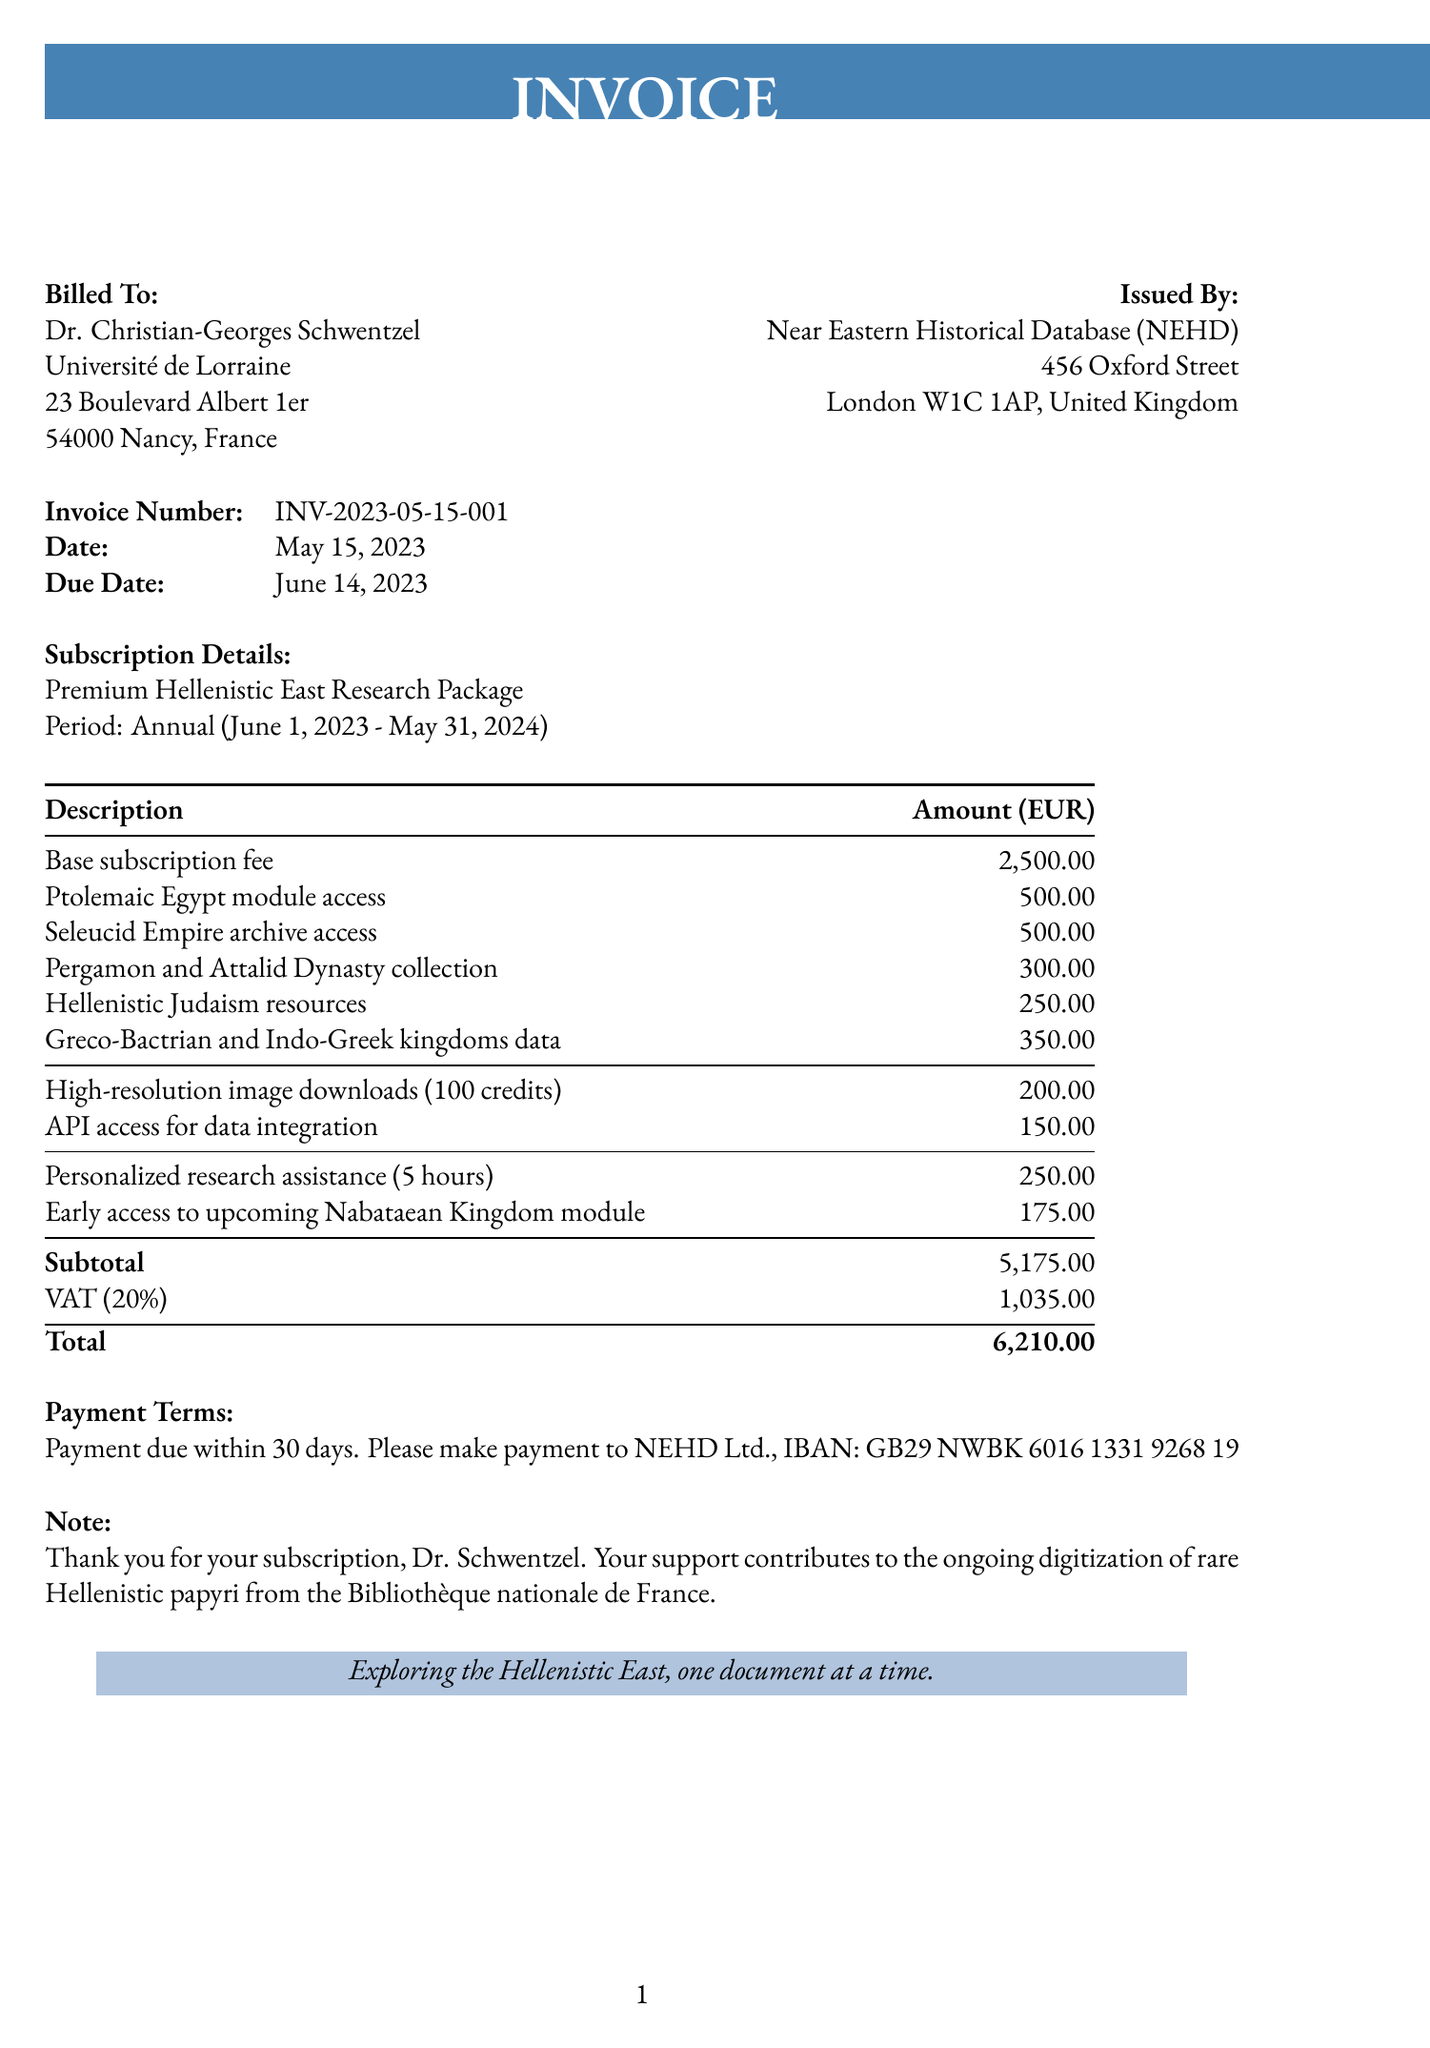What is the invoice number? The invoice number is stated in the document as a unique identifier for billing purposes.
Answer: INV-2023-05-15-001 What is the total amount due? The total amount is the final sum listed at the bottom of the invoice, which includes all charges and taxes.
Answer: 6210.00 What is the subscription plan labeled as? The subscription plan is specified in the invoice under the subscription details section.
Answer: Premium Hellenistic East Research Package When is the payment due? The due date is highlighted in the invoice and determines when the payment should be made.
Answer: June 14, 2023 How much is the base subscription fee? The base subscription fee is detailed in the line items section of the invoice.
Answer: 2500.00 What is the VAT percentage applied? The VAT percentage is indicated in the tax section of the invoice and affects the total calculation.
Answer: 20% How many hours of personalized research assistance are included? The number of hours for personalized research assistance is mentioned alongside the related charge in the additional services section.
Answer: 5 hours What additional service offers early access to a specific module? The document lists a service related to gaining advance access, which is part of the additional services offered.
Answer: Early access to upcoming Nabataean Kingdom module What institution is being billed in this invoice? The institution name is provided in the billing address section of the document.
Answer: Université de Lorraine 